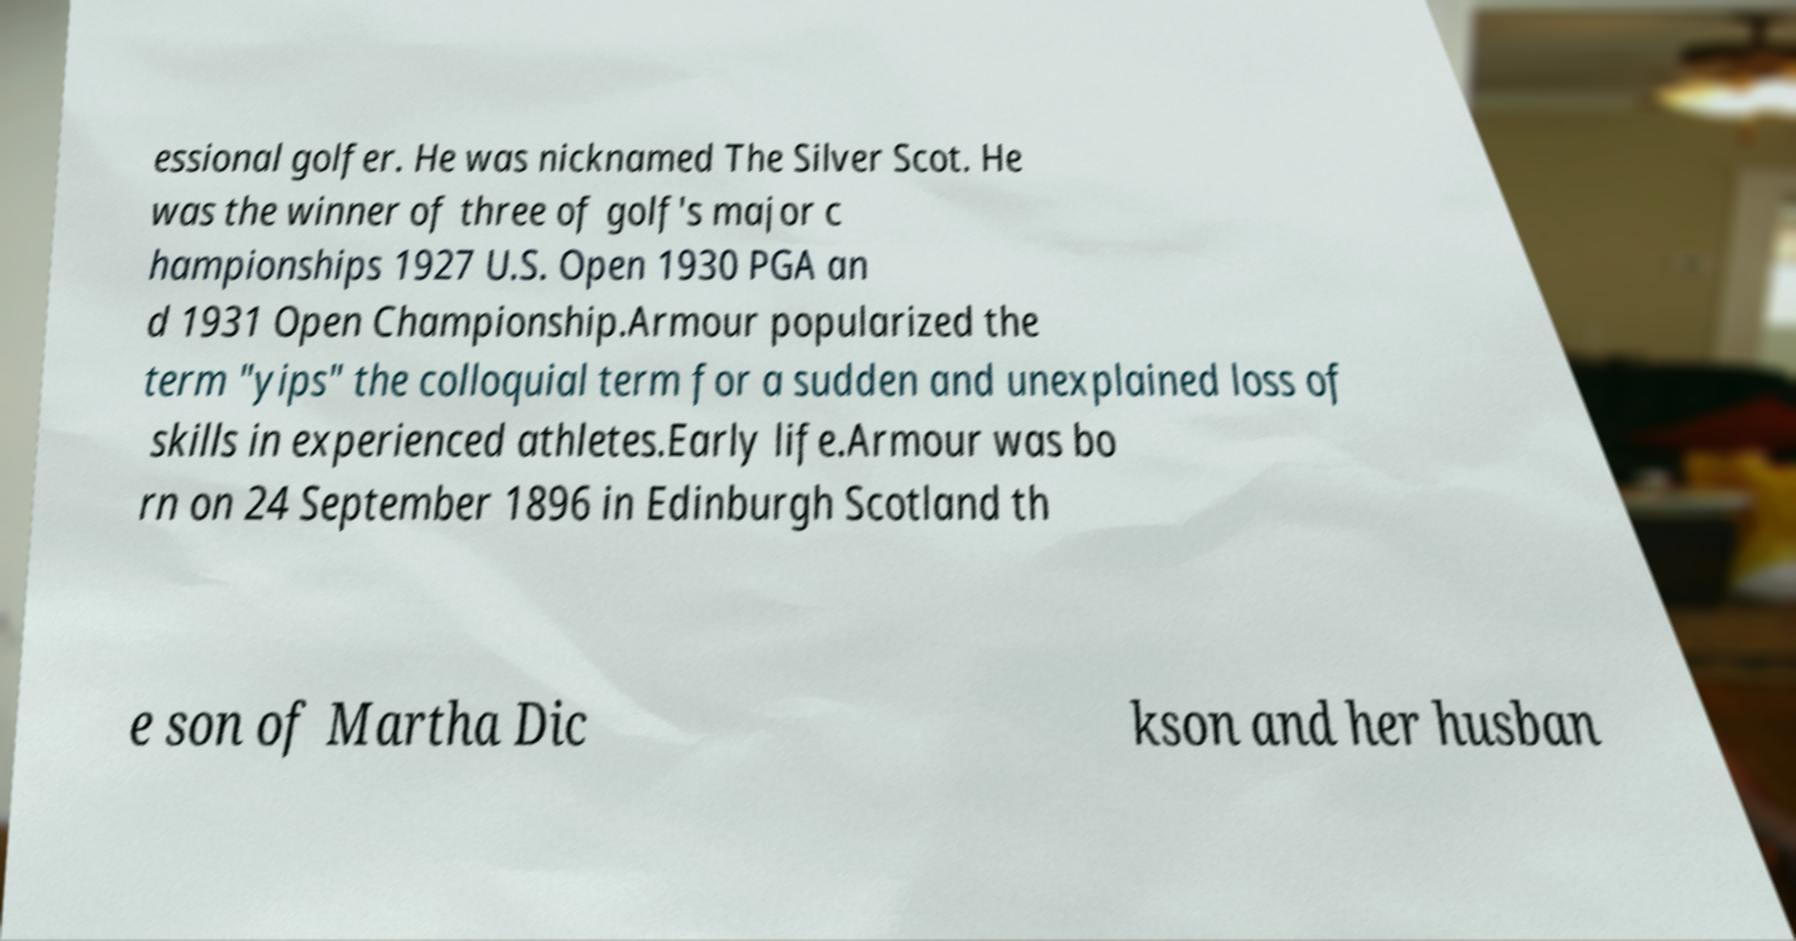Can you accurately transcribe the text from the provided image for me? essional golfer. He was nicknamed The Silver Scot. He was the winner of three of golf's major c hampionships 1927 U.S. Open 1930 PGA an d 1931 Open Championship.Armour popularized the term "yips" the colloquial term for a sudden and unexplained loss of skills in experienced athletes.Early life.Armour was bo rn on 24 September 1896 in Edinburgh Scotland th e son of Martha Dic kson and her husban 